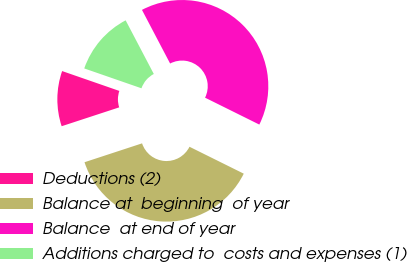<chart> <loc_0><loc_0><loc_500><loc_500><pie_chart><fcel>Deductions (2)<fcel>Balance at  beginning  of year<fcel>Balance  at end of year<fcel>Additions charged to  costs and expenses (1)<nl><fcel>10.36%<fcel>37.63%<fcel>40.02%<fcel>11.99%<nl></chart> 